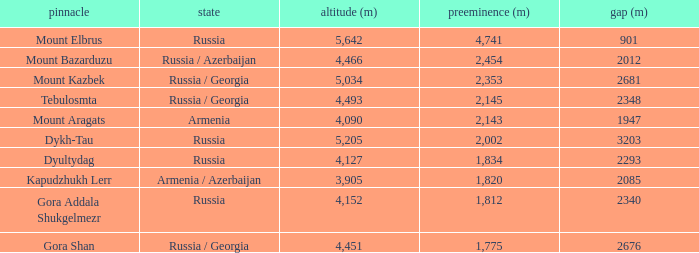What is the Col (m) of Peak Mount Aragats with an Elevation (m) larger than 3,905 and Prominence smaller than 2,143? None. 